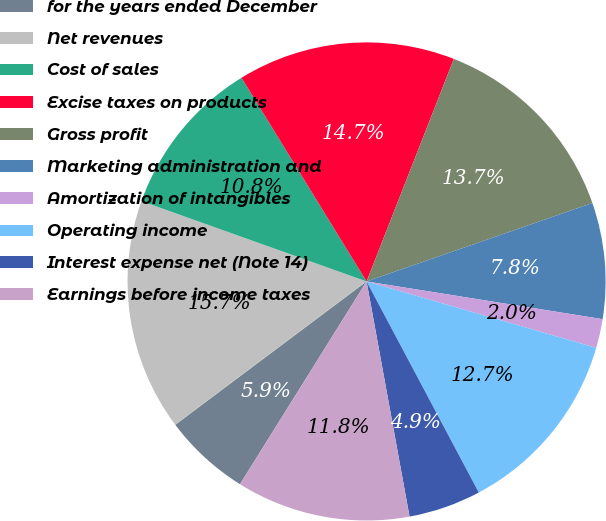<chart> <loc_0><loc_0><loc_500><loc_500><pie_chart><fcel>for the years ended December<fcel>Net revenues<fcel>Cost of sales<fcel>Excise taxes on products<fcel>Gross profit<fcel>Marketing administration and<fcel>Amortization of intangibles<fcel>Operating income<fcel>Interest expense net (Note 14)<fcel>Earnings before income taxes<nl><fcel>5.88%<fcel>15.69%<fcel>10.78%<fcel>14.71%<fcel>13.73%<fcel>7.84%<fcel>1.96%<fcel>12.74%<fcel>4.9%<fcel>11.76%<nl></chart> 